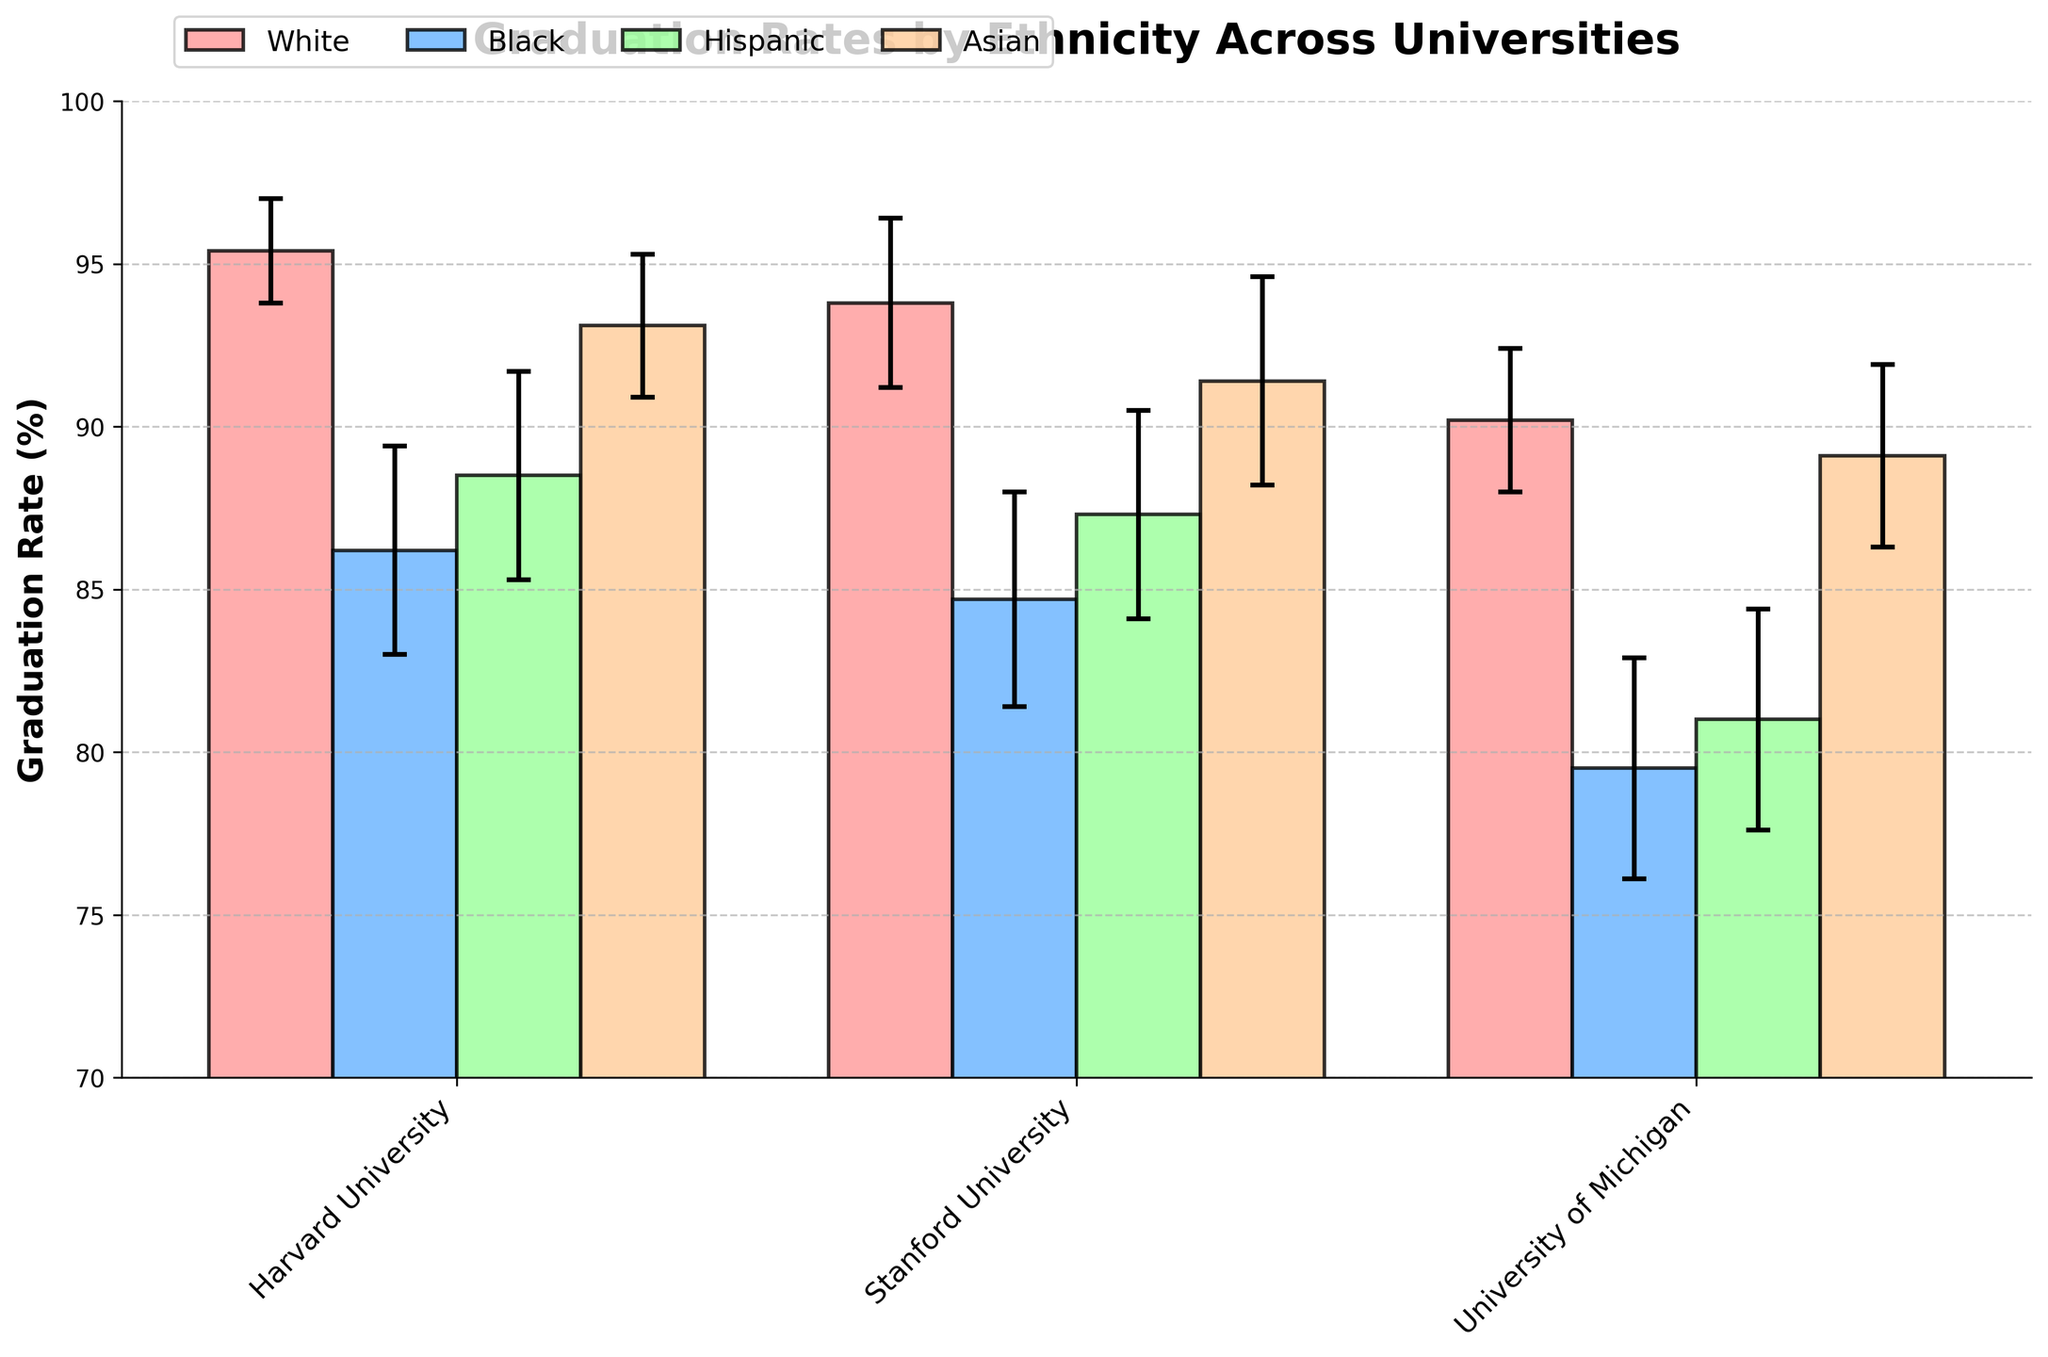what's the title of the figure? Look at the top of the figure where the title is usually located. It reads "Graduation Rates by Ethnicity Across Universities".
Answer: Graduation Rates by Ethnicity Across Universities Which ethnicity has the highest graduation rate at Harvard University? Find the bars labeled with Harvard University and compare the heights of the bars for each ethnicity. The highest bar is for White ethnicity at 95.4%.
Answer: White What is the range of the confidence interval for Black students' graduation rate at Stanford University? Look at the error bars for the Black students at Stanford University. The confidence interval lower and upper bounds are 81.4% and 88.0%. The range is 88.0% - 81.4% = 6.6%.
Answer: 6.6% Which university has the lowest graduation rate for Hispanic students? Compare the heights of the bars representing Hispanic students across all universities. The lowest bar is at the University of Michigan with a rate of 81.0%.
Answer: University of Michigan What's the difference in graduation rates for Asian students between Harvard University and University of Michigan? Look at the heights of the bars for Asian students at Harvard University and University of Michigan. The rates are 93.1% and 89.1%, respectively. The difference is 93.1% - 89.1% = 4.0%.
Answer: 4.0% What is the average graduation rate for Hispanic students across all universities? Sum the graduation rates for Hispanic students across the three universities: 88.5% (Harvard) + 87.3% (Stanford) + 81.0% (Michigan). Then divide by the number of universities: (88.5 + 87.3 + 81.0) / 3 = 85.6%.
Answer: 85.6% Which university has the smallest disparity in graduation rates between White and Black students? Calculate the disparity in graduation rates between White and Black students for each university: Harvard (95.4% - 86.2% = 9.2%), Stanford (93.8% - 84.7% = 9.1%), Michigan (90.2% - 79.5% = 10.7%). Stanford has the smallest disparity with 9.1%.
Answer: Stanford For which ethnicity do all universities have a graduation rate above 85%? Check the graduation rates for all ethnicities across the universities. White (all above 90%), Asian (all above 89%), and Hispanic (University of Michigan at 81.0%). Only White and Asian ethnicities are above 85%.
Answer: White, Asian 